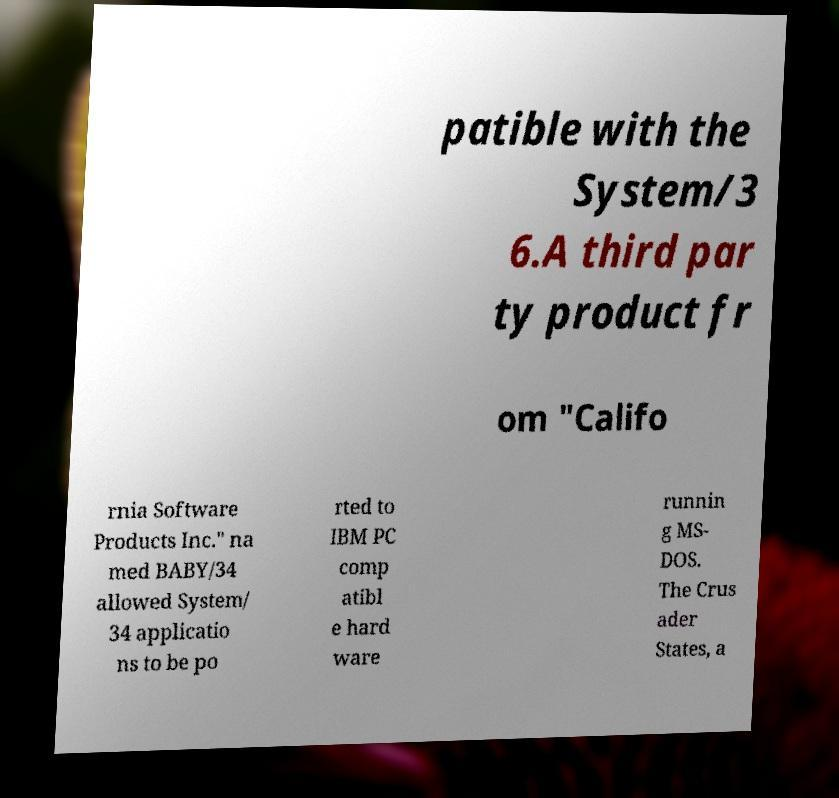Could you assist in decoding the text presented in this image and type it out clearly? patible with the System/3 6.A third par ty product fr om "Califo rnia Software Products Inc." na med BABY/34 allowed System/ 34 applicatio ns to be po rted to IBM PC comp atibl e hard ware runnin g MS- DOS. The Crus ader States, a 